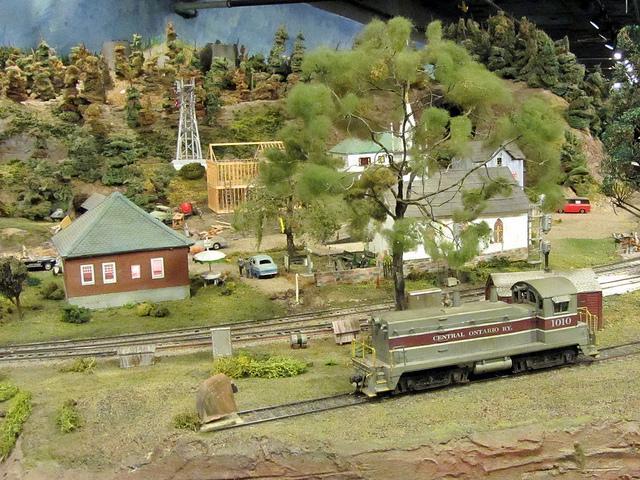What type of scene is this?
Make your selection from the four choices given to correctly answer the question.
Options: Power plant, train station, model, farm. Model. 